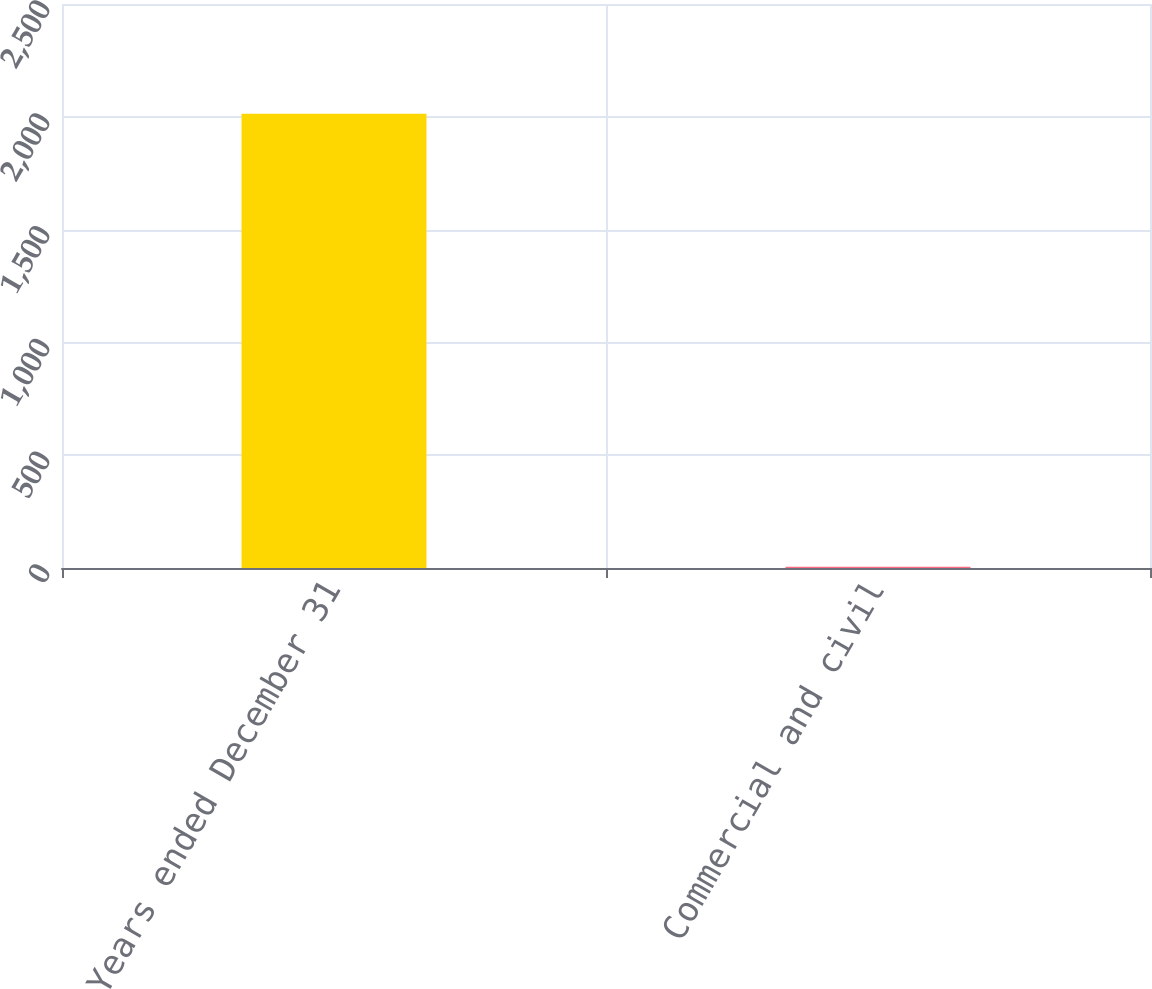Convert chart to OTSL. <chart><loc_0><loc_0><loc_500><loc_500><bar_chart><fcel>Years ended December 31<fcel>Commercial and civil<nl><fcel>2014<fcel>5<nl></chart> 